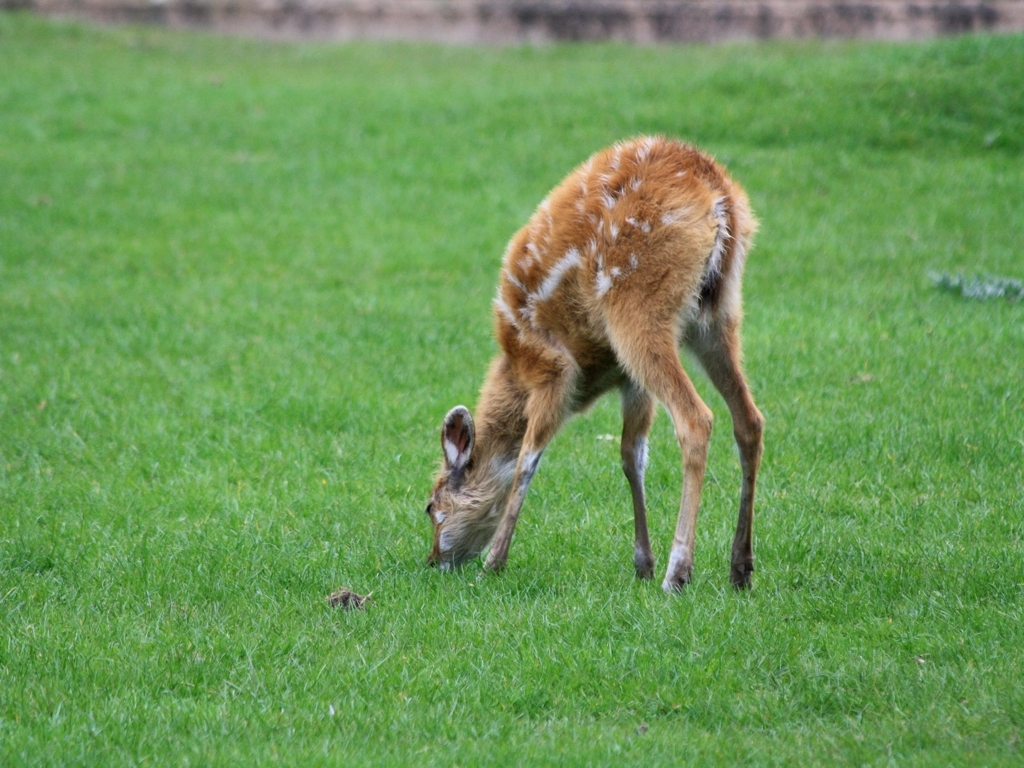Is the image very clear?
A. No
B. Yes
Answer with the option's letter from the given choices directly.
 B. 